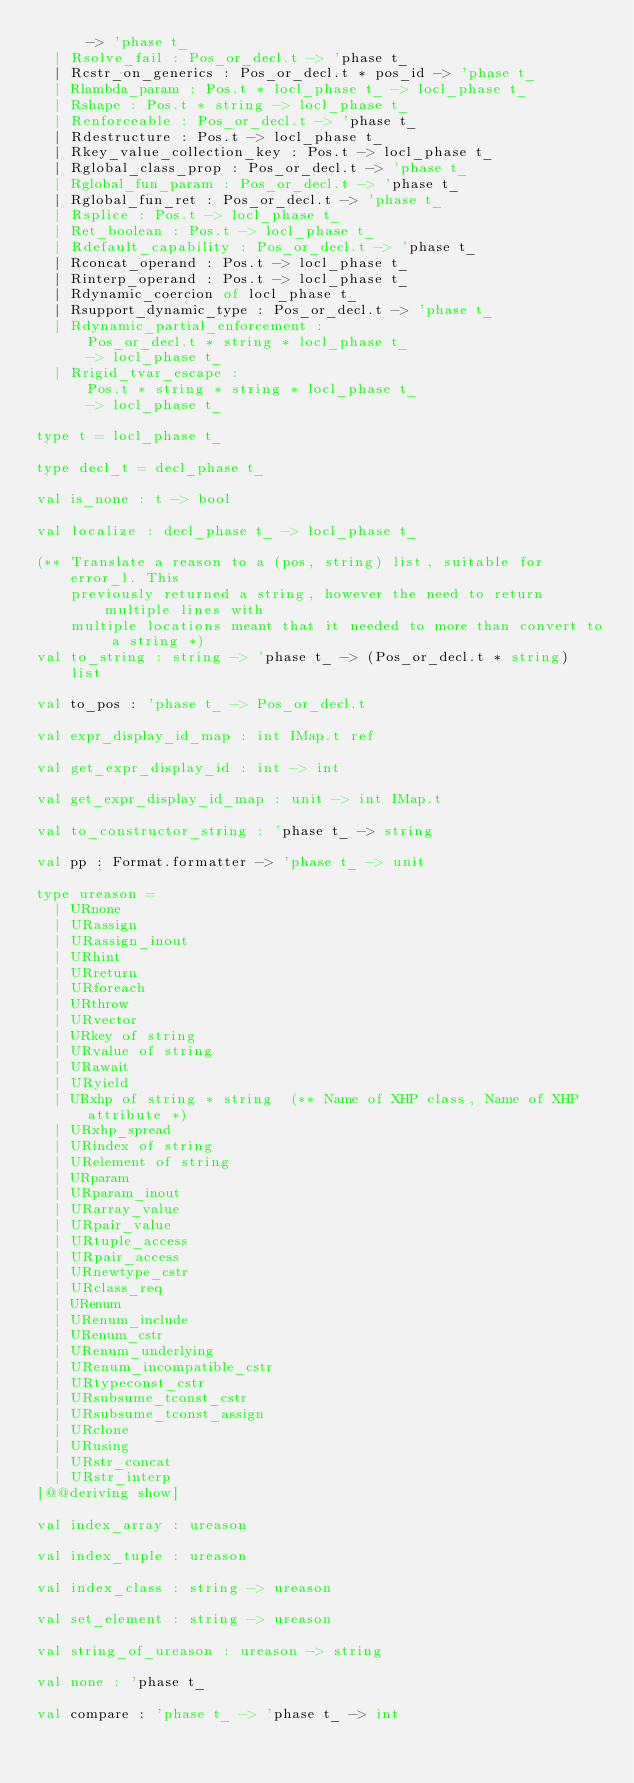<code> <loc_0><loc_0><loc_500><loc_500><_OCaml_>      -> 'phase t_
  | Rsolve_fail : Pos_or_decl.t -> 'phase t_
  | Rcstr_on_generics : Pos_or_decl.t * pos_id -> 'phase t_
  | Rlambda_param : Pos.t * locl_phase t_ -> locl_phase t_
  | Rshape : Pos.t * string -> locl_phase t_
  | Renforceable : Pos_or_decl.t -> 'phase t_
  | Rdestructure : Pos.t -> locl_phase t_
  | Rkey_value_collection_key : Pos.t -> locl_phase t_
  | Rglobal_class_prop : Pos_or_decl.t -> 'phase t_
  | Rglobal_fun_param : Pos_or_decl.t -> 'phase t_
  | Rglobal_fun_ret : Pos_or_decl.t -> 'phase t_
  | Rsplice : Pos.t -> locl_phase t_
  | Ret_boolean : Pos.t -> locl_phase t_
  | Rdefault_capability : Pos_or_decl.t -> 'phase t_
  | Rconcat_operand : Pos.t -> locl_phase t_
  | Rinterp_operand : Pos.t -> locl_phase t_
  | Rdynamic_coercion of locl_phase t_
  | Rsupport_dynamic_type : Pos_or_decl.t -> 'phase t_
  | Rdynamic_partial_enforcement :
      Pos_or_decl.t * string * locl_phase t_
      -> locl_phase t_
  | Rrigid_tvar_escape :
      Pos.t * string * string * locl_phase t_
      -> locl_phase t_

type t = locl_phase t_

type decl_t = decl_phase t_

val is_none : t -> bool

val localize : decl_phase t_ -> locl_phase t_

(** Translate a reason to a (pos, string) list, suitable for error_l. This
    previously returned a string, however the need to return multiple lines with
    multiple locations meant that it needed to more than convert to a string *)
val to_string : string -> 'phase t_ -> (Pos_or_decl.t * string) list

val to_pos : 'phase t_ -> Pos_or_decl.t

val expr_display_id_map : int IMap.t ref

val get_expr_display_id : int -> int

val get_expr_display_id_map : unit -> int IMap.t

val to_constructor_string : 'phase t_ -> string

val pp : Format.formatter -> 'phase t_ -> unit

type ureason =
  | URnone
  | URassign
  | URassign_inout
  | URhint
  | URreturn
  | URforeach
  | URthrow
  | URvector
  | URkey of string
  | URvalue of string
  | URawait
  | URyield
  | URxhp of string * string  (** Name of XHP class, Name of XHP attribute *)
  | URxhp_spread
  | URindex of string
  | URelement of string
  | URparam
  | URparam_inout
  | URarray_value
  | URpair_value
  | URtuple_access
  | URpair_access
  | URnewtype_cstr
  | URclass_req
  | URenum
  | URenum_include
  | URenum_cstr
  | URenum_underlying
  | URenum_incompatible_cstr
  | URtypeconst_cstr
  | URsubsume_tconst_cstr
  | URsubsume_tconst_assign
  | URclone
  | URusing
  | URstr_concat
  | URstr_interp
[@@deriving show]

val index_array : ureason

val index_tuple : ureason

val index_class : string -> ureason

val set_element : string -> ureason

val string_of_ureason : ureason -> string

val none : 'phase t_

val compare : 'phase t_ -> 'phase t_ -> int
</code> 